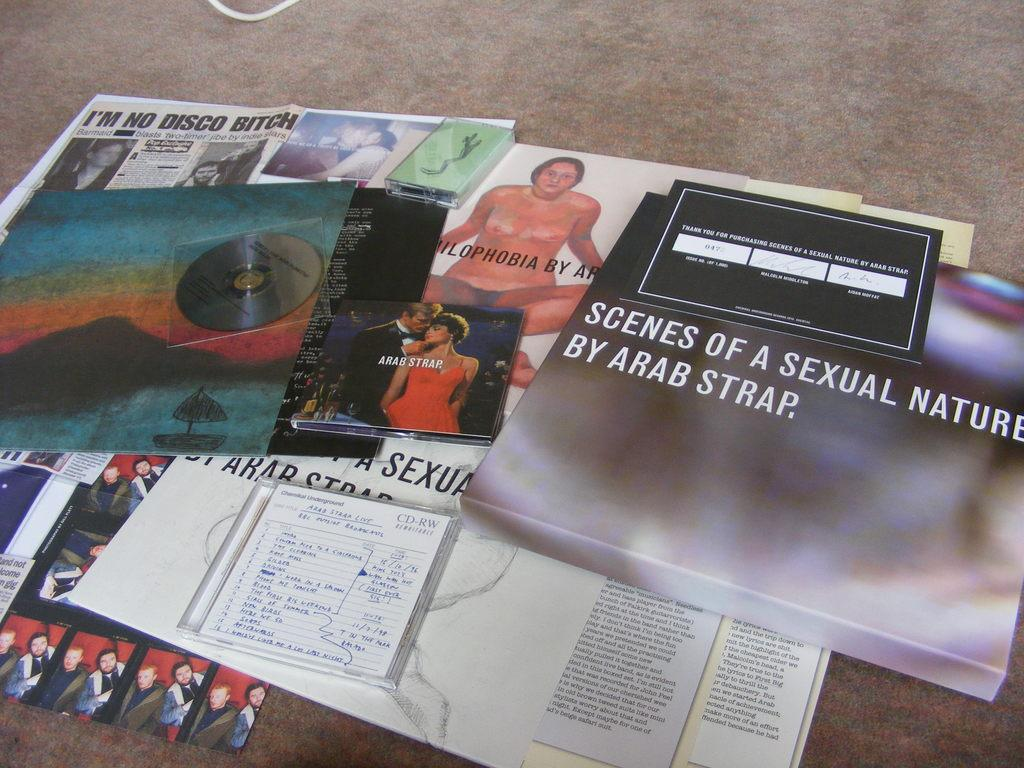What type of items can be seen on the floor in the image? There are papers, a CD, and a book on the floor in the image. What other objects are present on the floor in the image? There are other objects on the floor in the image, but their specific details are not mentioned in the provided facts. Can you describe one of the objects on the floor in the image? Yes, there is a book on the floor in the image. What type of help does the minister offer in the image? There is no minister or any indication of religious activity in the image. 